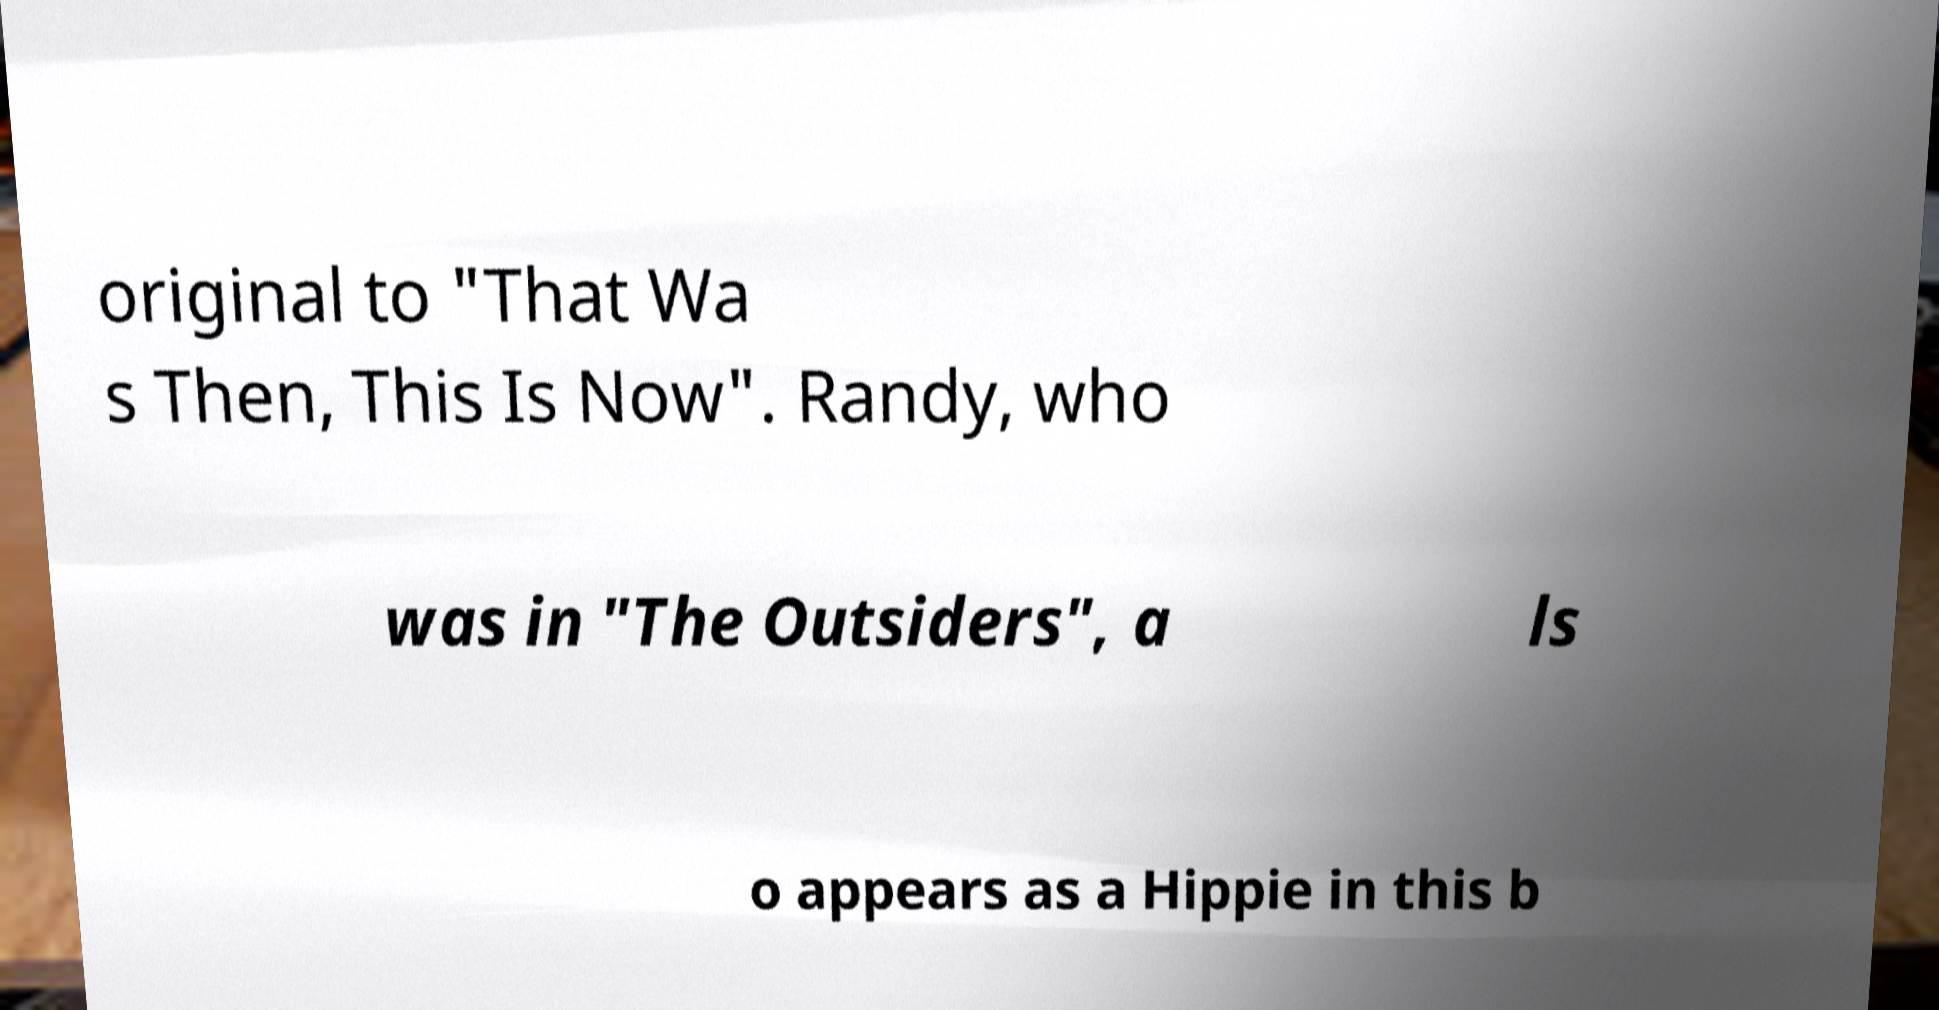Could you extract and type out the text from this image? original to "That Wa s Then, This Is Now". Randy, who was in "The Outsiders", a ls o appears as a Hippie in this b 